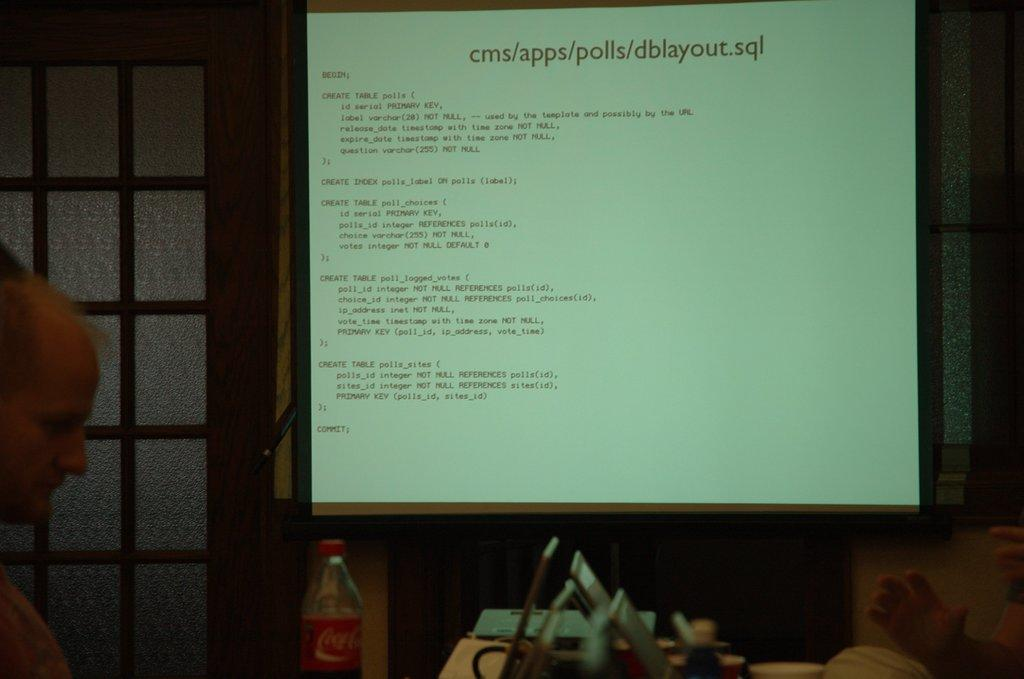What is being projected on the screen in the image? There is a screen projecting code in the image. Can you describe the person in the image? There is a man standing in one corner of the image. What type of lipstick is the man wearing in the image? There is no mention of lipstick or any cosmetics in the image, as it features a screen projecting code and a man standing in the corner. 